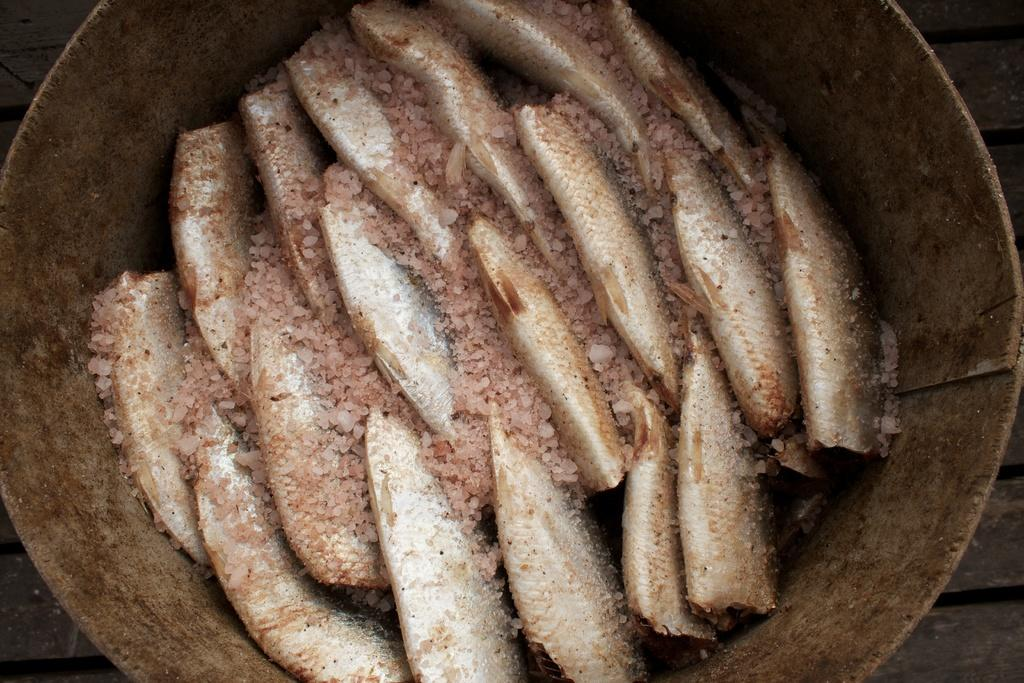What is inside the container in the image? There are fishes in the container. What is the container placed on? The container is on a wooden object. What type of religious agreement is depicted in the image? There is no religious agreement present in the image; it features a container with fishes placed on a wooden object. What type of wire is used to hold the container in the image? There is no wire present in the image; the container is placed on a wooden object. 